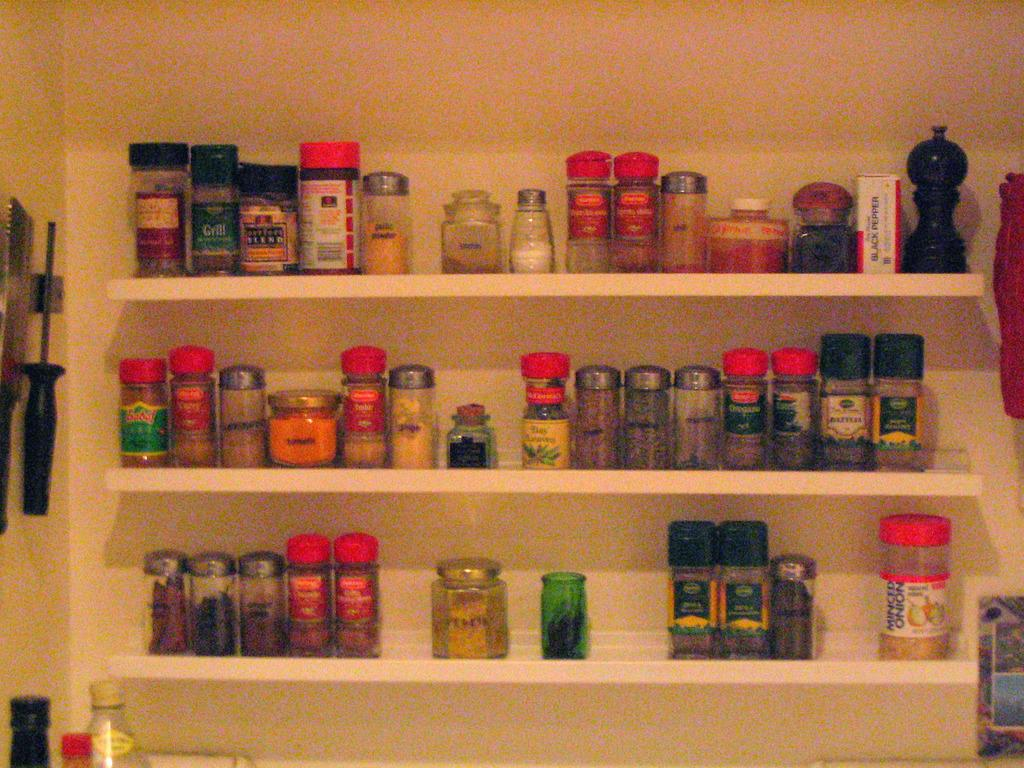What can be found in the containers in the image? There are different ingredients in the containers in the image. Where are the containers located? The containers are on shelves in the image. What else can be seen at the bottom left corner of the image? There are bottles at the bottom left corner of the image. How does the island society contribute to the point of the image? There is no island society or point mentioned in the image; it only features containers with ingredients on shelves and bottles at the bottom left corner. 